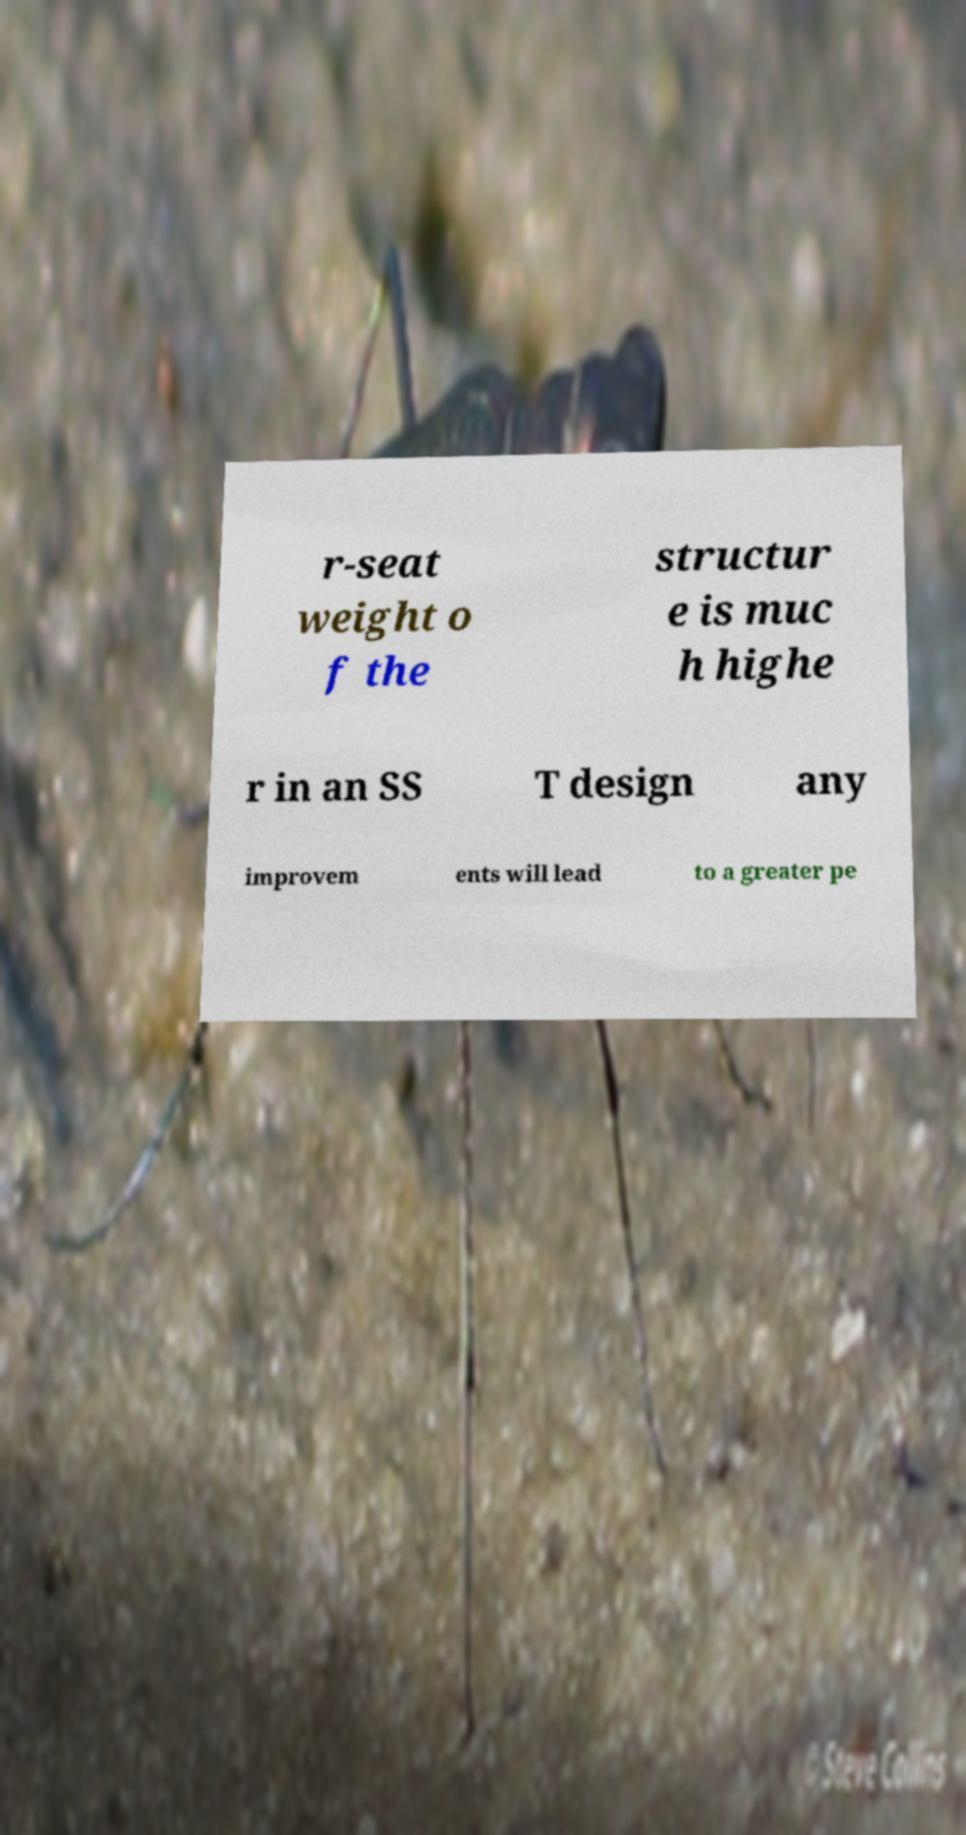Please identify and transcribe the text found in this image. r-seat weight o f the structur e is muc h highe r in an SS T design any improvem ents will lead to a greater pe 